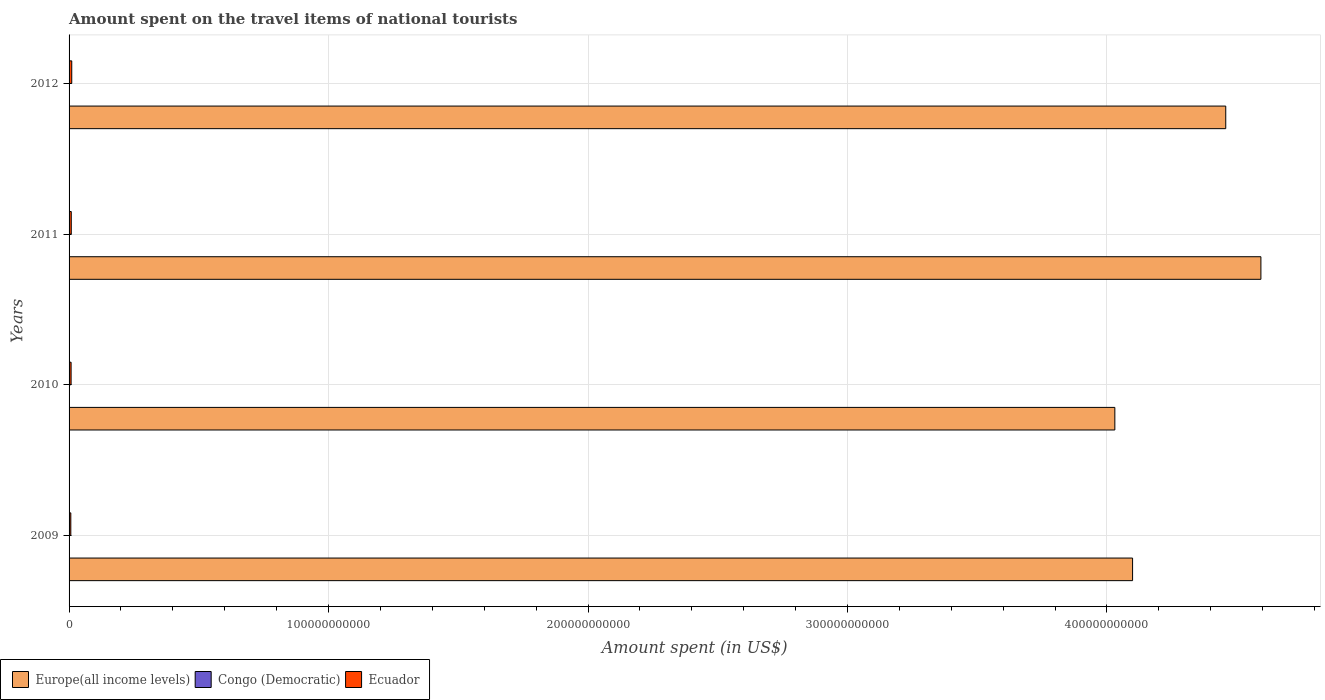How many different coloured bars are there?
Offer a very short reply. 3. How many groups of bars are there?
Provide a short and direct response. 4. Are the number of bars per tick equal to the number of legend labels?
Give a very brief answer. Yes. How many bars are there on the 2nd tick from the bottom?
Your answer should be compact. 3. In how many cases, is the number of bars for a given year not equal to the number of legend labels?
Ensure brevity in your answer.  0. What is the amount spent on the travel items of national tourists in Ecuador in 2009?
Keep it short and to the point. 6.70e+08. Across all years, what is the maximum amount spent on the travel items of national tourists in Ecuador?
Your answer should be compact. 1.03e+09. Across all years, what is the minimum amount spent on the travel items of national tourists in Europe(all income levels)?
Offer a very short reply. 4.03e+11. In which year was the amount spent on the travel items of national tourists in Europe(all income levels) minimum?
Ensure brevity in your answer.  2010. What is the total amount spent on the travel items of national tourists in Europe(all income levels) in the graph?
Your answer should be very brief. 1.72e+12. What is the difference between the amount spent on the travel items of national tourists in Ecuador in 2009 and that in 2011?
Offer a terse response. -1.73e+08. What is the difference between the amount spent on the travel items of national tourists in Ecuador in 2010 and the amount spent on the travel items of national tourists in Europe(all income levels) in 2011?
Ensure brevity in your answer.  -4.59e+11. What is the average amount spent on the travel items of national tourists in Congo (Democratic) per year?
Offer a very short reply. 1.32e+07. In the year 2012, what is the difference between the amount spent on the travel items of national tourists in Europe(all income levels) and amount spent on the travel items of national tourists in Ecuador?
Your answer should be compact. 4.45e+11. In how many years, is the amount spent on the travel items of national tourists in Europe(all income levels) greater than 100000000000 US$?
Offer a terse response. 4. What is the ratio of the amount spent on the travel items of national tourists in Ecuador in 2010 to that in 2012?
Offer a terse response. 0.76. Is the difference between the amount spent on the travel items of national tourists in Europe(all income levels) in 2009 and 2011 greater than the difference between the amount spent on the travel items of national tourists in Ecuador in 2009 and 2011?
Ensure brevity in your answer.  No. What is the difference between the highest and the second highest amount spent on the travel items of national tourists in Europe(all income levels)?
Provide a succinct answer. 1.35e+1. What is the difference between the highest and the lowest amount spent on the travel items of national tourists in Europe(all income levels)?
Your response must be concise. 5.63e+1. Is the sum of the amount spent on the travel items of national tourists in Congo (Democratic) in 2009 and 2012 greater than the maximum amount spent on the travel items of national tourists in Europe(all income levels) across all years?
Offer a very short reply. No. What does the 1st bar from the top in 2009 represents?
Ensure brevity in your answer.  Ecuador. What does the 1st bar from the bottom in 2010 represents?
Offer a very short reply. Europe(all income levels). Is it the case that in every year, the sum of the amount spent on the travel items of national tourists in Europe(all income levels) and amount spent on the travel items of national tourists in Ecuador is greater than the amount spent on the travel items of national tourists in Congo (Democratic)?
Make the answer very short. Yes. How many years are there in the graph?
Provide a succinct answer. 4. What is the difference between two consecutive major ticks on the X-axis?
Your answer should be very brief. 1.00e+11. Are the values on the major ticks of X-axis written in scientific E-notation?
Provide a short and direct response. No. How are the legend labels stacked?
Offer a very short reply. Horizontal. What is the title of the graph?
Your answer should be very brief. Amount spent on the travel items of national tourists. Does "Algeria" appear as one of the legend labels in the graph?
Offer a very short reply. No. What is the label or title of the X-axis?
Your answer should be compact. Amount spent (in US$). What is the label or title of the Y-axis?
Your answer should be very brief. Years. What is the Amount spent (in US$) of Europe(all income levels) in 2009?
Your answer should be compact. 4.10e+11. What is the Amount spent (in US$) of Congo (Democratic) in 2009?
Make the answer very short. 2.40e+07. What is the Amount spent (in US$) in Ecuador in 2009?
Your answer should be very brief. 6.70e+08. What is the Amount spent (in US$) in Europe(all income levels) in 2010?
Provide a short and direct response. 4.03e+11. What is the Amount spent (in US$) of Congo (Democratic) in 2010?
Give a very brief answer. 1.07e+07. What is the Amount spent (in US$) of Ecuador in 2010?
Provide a succinct answer. 7.81e+08. What is the Amount spent (in US$) of Europe(all income levels) in 2011?
Your answer should be very brief. 4.59e+11. What is the Amount spent (in US$) of Congo (Democratic) in 2011?
Give a very brief answer. 1.14e+07. What is the Amount spent (in US$) of Ecuador in 2011?
Give a very brief answer. 8.43e+08. What is the Amount spent (in US$) in Europe(all income levels) in 2012?
Offer a terse response. 4.46e+11. What is the Amount spent (in US$) in Congo (Democratic) in 2012?
Keep it short and to the point. 6.90e+06. What is the Amount spent (in US$) in Ecuador in 2012?
Keep it short and to the point. 1.03e+09. Across all years, what is the maximum Amount spent (in US$) of Europe(all income levels)?
Provide a short and direct response. 4.59e+11. Across all years, what is the maximum Amount spent (in US$) in Congo (Democratic)?
Make the answer very short. 2.40e+07. Across all years, what is the maximum Amount spent (in US$) in Ecuador?
Your answer should be very brief. 1.03e+09. Across all years, what is the minimum Amount spent (in US$) in Europe(all income levels)?
Offer a terse response. 4.03e+11. Across all years, what is the minimum Amount spent (in US$) of Congo (Democratic)?
Offer a very short reply. 6.90e+06. Across all years, what is the minimum Amount spent (in US$) of Ecuador?
Offer a terse response. 6.70e+08. What is the total Amount spent (in US$) in Europe(all income levels) in the graph?
Give a very brief answer. 1.72e+12. What is the total Amount spent (in US$) of Congo (Democratic) in the graph?
Ensure brevity in your answer.  5.30e+07. What is the total Amount spent (in US$) in Ecuador in the graph?
Make the answer very short. 3.33e+09. What is the difference between the Amount spent (in US$) of Europe(all income levels) in 2009 and that in 2010?
Your response must be concise. 6.83e+09. What is the difference between the Amount spent (in US$) of Congo (Democratic) in 2009 and that in 2010?
Keep it short and to the point. 1.33e+07. What is the difference between the Amount spent (in US$) of Ecuador in 2009 and that in 2010?
Your response must be concise. -1.11e+08. What is the difference between the Amount spent (in US$) of Europe(all income levels) in 2009 and that in 2011?
Your answer should be very brief. -4.95e+1. What is the difference between the Amount spent (in US$) in Congo (Democratic) in 2009 and that in 2011?
Your response must be concise. 1.26e+07. What is the difference between the Amount spent (in US$) of Ecuador in 2009 and that in 2011?
Ensure brevity in your answer.  -1.73e+08. What is the difference between the Amount spent (in US$) of Europe(all income levels) in 2009 and that in 2012?
Ensure brevity in your answer.  -3.59e+1. What is the difference between the Amount spent (in US$) in Congo (Democratic) in 2009 and that in 2012?
Your answer should be very brief. 1.71e+07. What is the difference between the Amount spent (in US$) of Ecuador in 2009 and that in 2012?
Ensure brevity in your answer.  -3.63e+08. What is the difference between the Amount spent (in US$) of Europe(all income levels) in 2010 and that in 2011?
Offer a terse response. -5.63e+1. What is the difference between the Amount spent (in US$) of Congo (Democratic) in 2010 and that in 2011?
Give a very brief answer. -7.00e+05. What is the difference between the Amount spent (in US$) in Ecuador in 2010 and that in 2011?
Give a very brief answer. -6.20e+07. What is the difference between the Amount spent (in US$) in Europe(all income levels) in 2010 and that in 2012?
Offer a very short reply. -4.27e+1. What is the difference between the Amount spent (in US$) of Congo (Democratic) in 2010 and that in 2012?
Provide a short and direct response. 3.80e+06. What is the difference between the Amount spent (in US$) of Ecuador in 2010 and that in 2012?
Your answer should be very brief. -2.52e+08. What is the difference between the Amount spent (in US$) in Europe(all income levels) in 2011 and that in 2012?
Make the answer very short. 1.35e+1. What is the difference between the Amount spent (in US$) of Congo (Democratic) in 2011 and that in 2012?
Offer a terse response. 4.50e+06. What is the difference between the Amount spent (in US$) of Ecuador in 2011 and that in 2012?
Provide a succinct answer. -1.90e+08. What is the difference between the Amount spent (in US$) in Europe(all income levels) in 2009 and the Amount spent (in US$) in Congo (Democratic) in 2010?
Ensure brevity in your answer.  4.10e+11. What is the difference between the Amount spent (in US$) in Europe(all income levels) in 2009 and the Amount spent (in US$) in Ecuador in 2010?
Offer a terse response. 4.09e+11. What is the difference between the Amount spent (in US$) of Congo (Democratic) in 2009 and the Amount spent (in US$) of Ecuador in 2010?
Your answer should be very brief. -7.57e+08. What is the difference between the Amount spent (in US$) in Europe(all income levels) in 2009 and the Amount spent (in US$) in Congo (Democratic) in 2011?
Keep it short and to the point. 4.10e+11. What is the difference between the Amount spent (in US$) in Europe(all income levels) in 2009 and the Amount spent (in US$) in Ecuador in 2011?
Provide a short and direct response. 4.09e+11. What is the difference between the Amount spent (in US$) in Congo (Democratic) in 2009 and the Amount spent (in US$) in Ecuador in 2011?
Offer a terse response. -8.19e+08. What is the difference between the Amount spent (in US$) in Europe(all income levels) in 2009 and the Amount spent (in US$) in Congo (Democratic) in 2012?
Ensure brevity in your answer.  4.10e+11. What is the difference between the Amount spent (in US$) in Europe(all income levels) in 2009 and the Amount spent (in US$) in Ecuador in 2012?
Your response must be concise. 4.09e+11. What is the difference between the Amount spent (in US$) of Congo (Democratic) in 2009 and the Amount spent (in US$) of Ecuador in 2012?
Offer a terse response. -1.01e+09. What is the difference between the Amount spent (in US$) in Europe(all income levels) in 2010 and the Amount spent (in US$) in Congo (Democratic) in 2011?
Provide a succinct answer. 4.03e+11. What is the difference between the Amount spent (in US$) in Europe(all income levels) in 2010 and the Amount spent (in US$) in Ecuador in 2011?
Make the answer very short. 4.02e+11. What is the difference between the Amount spent (in US$) in Congo (Democratic) in 2010 and the Amount spent (in US$) in Ecuador in 2011?
Provide a short and direct response. -8.32e+08. What is the difference between the Amount spent (in US$) of Europe(all income levels) in 2010 and the Amount spent (in US$) of Congo (Democratic) in 2012?
Keep it short and to the point. 4.03e+11. What is the difference between the Amount spent (in US$) in Europe(all income levels) in 2010 and the Amount spent (in US$) in Ecuador in 2012?
Keep it short and to the point. 4.02e+11. What is the difference between the Amount spent (in US$) in Congo (Democratic) in 2010 and the Amount spent (in US$) in Ecuador in 2012?
Give a very brief answer. -1.02e+09. What is the difference between the Amount spent (in US$) in Europe(all income levels) in 2011 and the Amount spent (in US$) in Congo (Democratic) in 2012?
Keep it short and to the point. 4.59e+11. What is the difference between the Amount spent (in US$) in Europe(all income levels) in 2011 and the Amount spent (in US$) in Ecuador in 2012?
Ensure brevity in your answer.  4.58e+11. What is the difference between the Amount spent (in US$) in Congo (Democratic) in 2011 and the Amount spent (in US$) in Ecuador in 2012?
Your response must be concise. -1.02e+09. What is the average Amount spent (in US$) in Europe(all income levels) per year?
Give a very brief answer. 4.29e+11. What is the average Amount spent (in US$) of Congo (Democratic) per year?
Your answer should be compact. 1.32e+07. What is the average Amount spent (in US$) in Ecuador per year?
Give a very brief answer. 8.32e+08. In the year 2009, what is the difference between the Amount spent (in US$) of Europe(all income levels) and Amount spent (in US$) of Congo (Democratic)?
Your response must be concise. 4.10e+11. In the year 2009, what is the difference between the Amount spent (in US$) in Europe(all income levels) and Amount spent (in US$) in Ecuador?
Offer a very short reply. 4.09e+11. In the year 2009, what is the difference between the Amount spent (in US$) of Congo (Democratic) and Amount spent (in US$) of Ecuador?
Give a very brief answer. -6.46e+08. In the year 2010, what is the difference between the Amount spent (in US$) of Europe(all income levels) and Amount spent (in US$) of Congo (Democratic)?
Keep it short and to the point. 4.03e+11. In the year 2010, what is the difference between the Amount spent (in US$) in Europe(all income levels) and Amount spent (in US$) in Ecuador?
Ensure brevity in your answer.  4.02e+11. In the year 2010, what is the difference between the Amount spent (in US$) of Congo (Democratic) and Amount spent (in US$) of Ecuador?
Your answer should be compact. -7.70e+08. In the year 2011, what is the difference between the Amount spent (in US$) of Europe(all income levels) and Amount spent (in US$) of Congo (Democratic)?
Ensure brevity in your answer.  4.59e+11. In the year 2011, what is the difference between the Amount spent (in US$) in Europe(all income levels) and Amount spent (in US$) in Ecuador?
Provide a succinct answer. 4.58e+11. In the year 2011, what is the difference between the Amount spent (in US$) of Congo (Democratic) and Amount spent (in US$) of Ecuador?
Your answer should be very brief. -8.32e+08. In the year 2012, what is the difference between the Amount spent (in US$) of Europe(all income levels) and Amount spent (in US$) of Congo (Democratic)?
Offer a very short reply. 4.46e+11. In the year 2012, what is the difference between the Amount spent (in US$) in Europe(all income levels) and Amount spent (in US$) in Ecuador?
Provide a succinct answer. 4.45e+11. In the year 2012, what is the difference between the Amount spent (in US$) in Congo (Democratic) and Amount spent (in US$) in Ecuador?
Your answer should be very brief. -1.03e+09. What is the ratio of the Amount spent (in US$) in Europe(all income levels) in 2009 to that in 2010?
Your response must be concise. 1.02. What is the ratio of the Amount spent (in US$) of Congo (Democratic) in 2009 to that in 2010?
Your response must be concise. 2.24. What is the ratio of the Amount spent (in US$) of Ecuador in 2009 to that in 2010?
Your answer should be very brief. 0.86. What is the ratio of the Amount spent (in US$) in Europe(all income levels) in 2009 to that in 2011?
Offer a terse response. 0.89. What is the ratio of the Amount spent (in US$) of Congo (Democratic) in 2009 to that in 2011?
Offer a very short reply. 2.11. What is the ratio of the Amount spent (in US$) in Ecuador in 2009 to that in 2011?
Your answer should be very brief. 0.79. What is the ratio of the Amount spent (in US$) of Europe(all income levels) in 2009 to that in 2012?
Offer a terse response. 0.92. What is the ratio of the Amount spent (in US$) in Congo (Democratic) in 2009 to that in 2012?
Provide a succinct answer. 3.48. What is the ratio of the Amount spent (in US$) of Ecuador in 2009 to that in 2012?
Provide a succinct answer. 0.65. What is the ratio of the Amount spent (in US$) in Europe(all income levels) in 2010 to that in 2011?
Keep it short and to the point. 0.88. What is the ratio of the Amount spent (in US$) of Congo (Democratic) in 2010 to that in 2011?
Make the answer very short. 0.94. What is the ratio of the Amount spent (in US$) of Ecuador in 2010 to that in 2011?
Offer a terse response. 0.93. What is the ratio of the Amount spent (in US$) in Europe(all income levels) in 2010 to that in 2012?
Provide a short and direct response. 0.9. What is the ratio of the Amount spent (in US$) in Congo (Democratic) in 2010 to that in 2012?
Give a very brief answer. 1.55. What is the ratio of the Amount spent (in US$) of Ecuador in 2010 to that in 2012?
Your response must be concise. 0.76. What is the ratio of the Amount spent (in US$) in Europe(all income levels) in 2011 to that in 2012?
Keep it short and to the point. 1.03. What is the ratio of the Amount spent (in US$) of Congo (Democratic) in 2011 to that in 2012?
Offer a terse response. 1.65. What is the ratio of the Amount spent (in US$) in Ecuador in 2011 to that in 2012?
Give a very brief answer. 0.82. What is the difference between the highest and the second highest Amount spent (in US$) in Europe(all income levels)?
Your answer should be very brief. 1.35e+1. What is the difference between the highest and the second highest Amount spent (in US$) in Congo (Democratic)?
Ensure brevity in your answer.  1.26e+07. What is the difference between the highest and the second highest Amount spent (in US$) of Ecuador?
Keep it short and to the point. 1.90e+08. What is the difference between the highest and the lowest Amount spent (in US$) of Europe(all income levels)?
Your answer should be compact. 5.63e+1. What is the difference between the highest and the lowest Amount spent (in US$) of Congo (Democratic)?
Your response must be concise. 1.71e+07. What is the difference between the highest and the lowest Amount spent (in US$) of Ecuador?
Ensure brevity in your answer.  3.63e+08. 